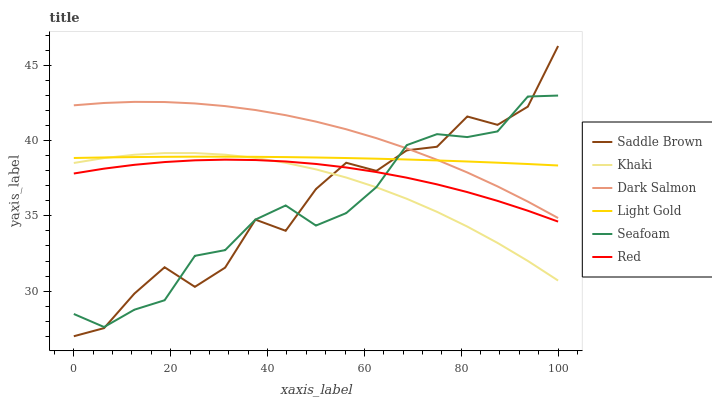Does Dark Salmon have the minimum area under the curve?
Answer yes or no. No. Does Seafoam have the maximum area under the curve?
Answer yes or no. No. Is Seafoam the smoothest?
Answer yes or no. No. Is Seafoam the roughest?
Answer yes or no. No. Does Seafoam have the lowest value?
Answer yes or no. No. Does Seafoam have the highest value?
Answer yes or no. No. Is Khaki less than Dark Salmon?
Answer yes or no. Yes. Is Dark Salmon greater than Red?
Answer yes or no. Yes. Does Khaki intersect Dark Salmon?
Answer yes or no. No. 